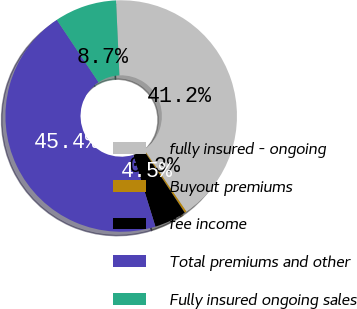Convert chart. <chart><loc_0><loc_0><loc_500><loc_500><pie_chart><fcel>fully insured - ongoing<fcel>Buyout premiums<fcel>fee income<fcel>Total premiums and other<fcel>Fully insured ongoing sales<nl><fcel>41.19%<fcel>0.27%<fcel>4.48%<fcel>45.39%<fcel>8.68%<nl></chart> 